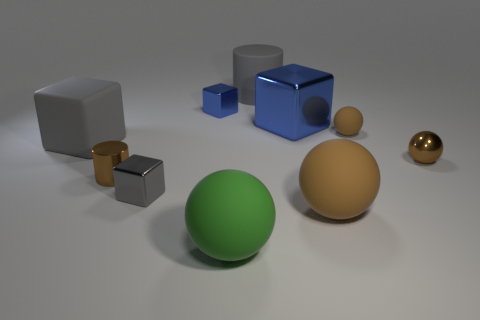Is there another green object that has the same shape as the green rubber object?
Make the answer very short. No. There is a brown shiny object that is the same size as the brown cylinder; what is its shape?
Your answer should be compact. Sphere. The small blue thing that is behind the big block on the left side of the tiny shiny cube that is in front of the large shiny thing is made of what material?
Keep it short and to the point. Metal. Do the brown cylinder and the rubber cube have the same size?
Offer a very short reply. No. What is the big blue cube made of?
Offer a very short reply. Metal. What is the material of the tiny object that is the same color as the matte cube?
Offer a terse response. Metal. Does the large gray rubber object that is to the left of the small brown metal cylinder have the same shape as the big green matte thing?
Provide a succinct answer. No. How many things are brown balls or big balls?
Your answer should be compact. 4. Does the gray cube on the left side of the small gray shiny object have the same material as the big blue object?
Give a very brief answer. No. What size is the gray cylinder?
Offer a terse response. Large. 